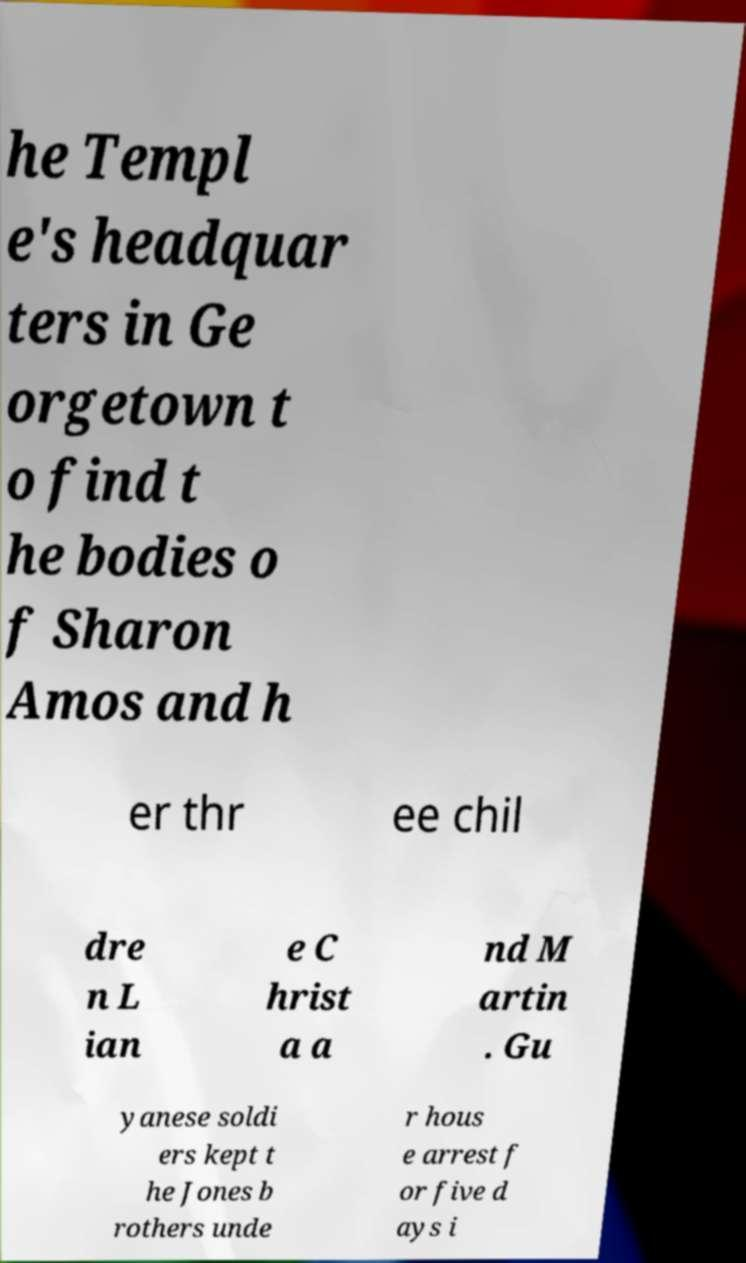Can you accurately transcribe the text from the provided image for me? he Templ e's headquar ters in Ge orgetown t o find t he bodies o f Sharon Amos and h er thr ee chil dre n L ian e C hrist a a nd M artin . Gu yanese soldi ers kept t he Jones b rothers unde r hous e arrest f or five d ays i 